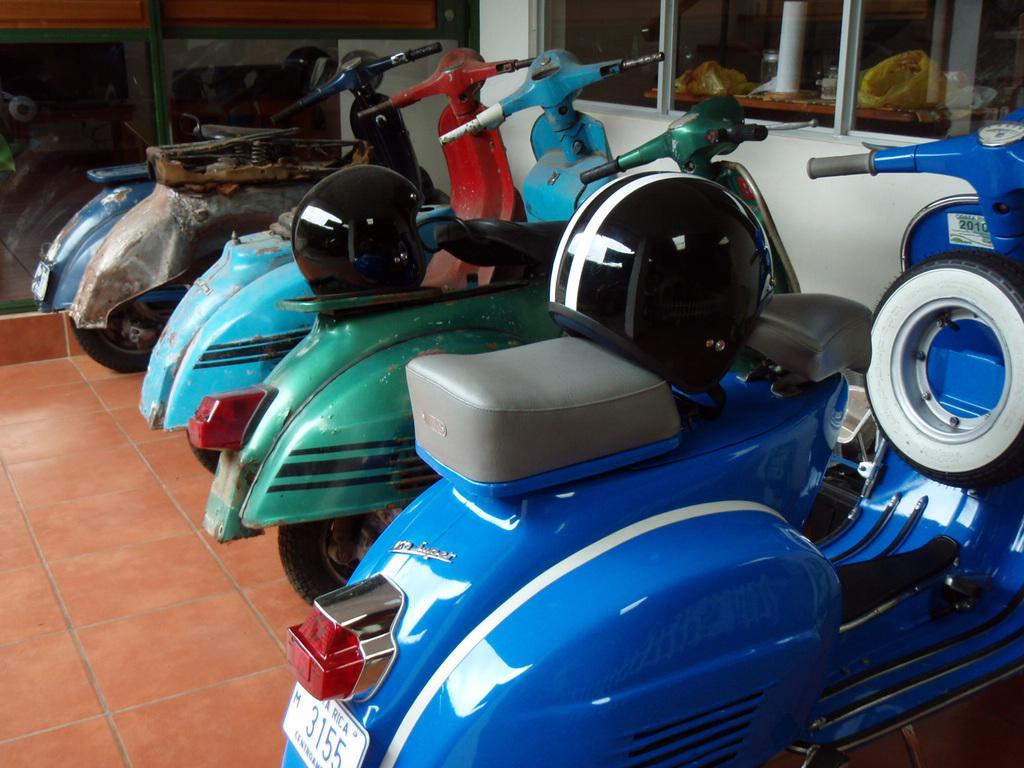How many scooters are in the image? There are 5 scooters in the image. What can be said about the colors of the scooters? The scooters are of different colors. How many helmets are visible in the image? There are 2 helmets in the image. What is visible beneath the scooters and helmets? The floor is visible in the image. What can be seen in the background of the image? There are glasses and a white wall in the background of the image. What type of detail can be seen on the lamp in the image? There is no lamp present in the image. 